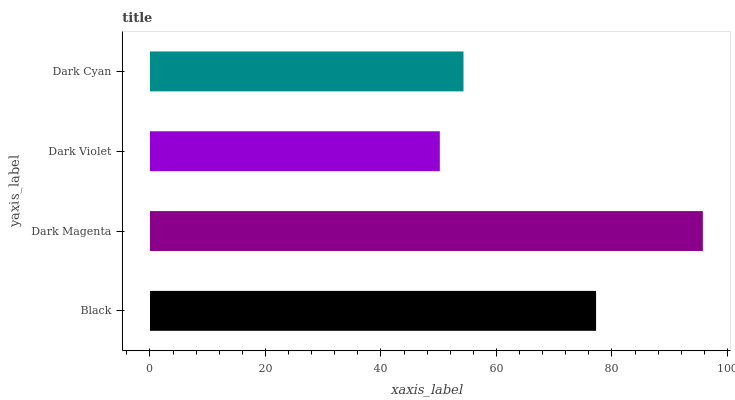Is Dark Violet the minimum?
Answer yes or no. Yes. Is Dark Magenta the maximum?
Answer yes or no. Yes. Is Dark Magenta the minimum?
Answer yes or no. No. Is Dark Violet the maximum?
Answer yes or no. No. Is Dark Magenta greater than Dark Violet?
Answer yes or no. Yes. Is Dark Violet less than Dark Magenta?
Answer yes or no. Yes. Is Dark Violet greater than Dark Magenta?
Answer yes or no. No. Is Dark Magenta less than Dark Violet?
Answer yes or no. No. Is Black the high median?
Answer yes or no. Yes. Is Dark Cyan the low median?
Answer yes or no. Yes. Is Dark Magenta the high median?
Answer yes or no. No. Is Black the low median?
Answer yes or no. No. 